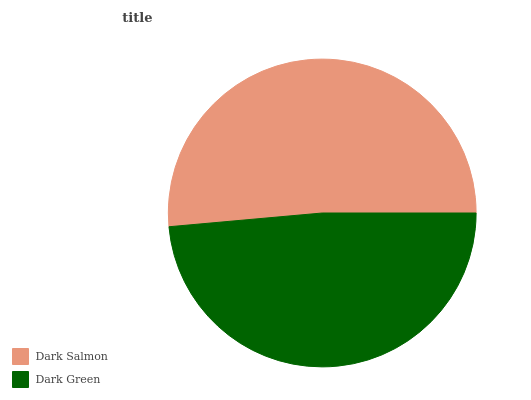Is Dark Green the minimum?
Answer yes or no. Yes. Is Dark Salmon the maximum?
Answer yes or no. Yes. Is Dark Green the maximum?
Answer yes or no. No. Is Dark Salmon greater than Dark Green?
Answer yes or no. Yes. Is Dark Green less than Dark Salmon?
Answer yes or no. Yes. Is Dark Green greater than Dark Salmon?
Answer yes or no. No. Is Dark Salmon less than Dark Green?
Answer yes or no. No. Is Dark Salmon the high median?
Answer yes or no. Yes. Is Dark Green the low median?
Answer yes or no. Yes. Is Dark Green the high median?
Answer yes or no. No. Is Dark Salmon the low median?
Answer yes or no. No. 